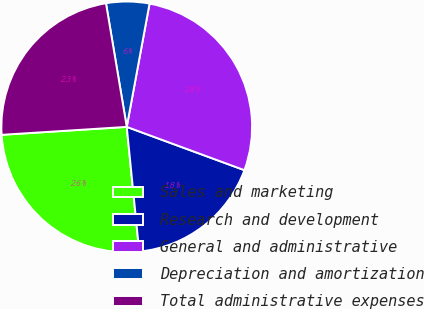Convert chart. <chart><loc_0><loc_0><loc_500><loc_500><pie_chart><fcel>Sales and marketing<fcel>Research and development<fcel>General and administrative<fcel>Depreciation and amortization<fcel>Total administrative expenses<nl><fcel>25.58%<fcel>17.8%<fcel>27.7%<fcel>5.56%<fcel>23.36%<nl></chart> 